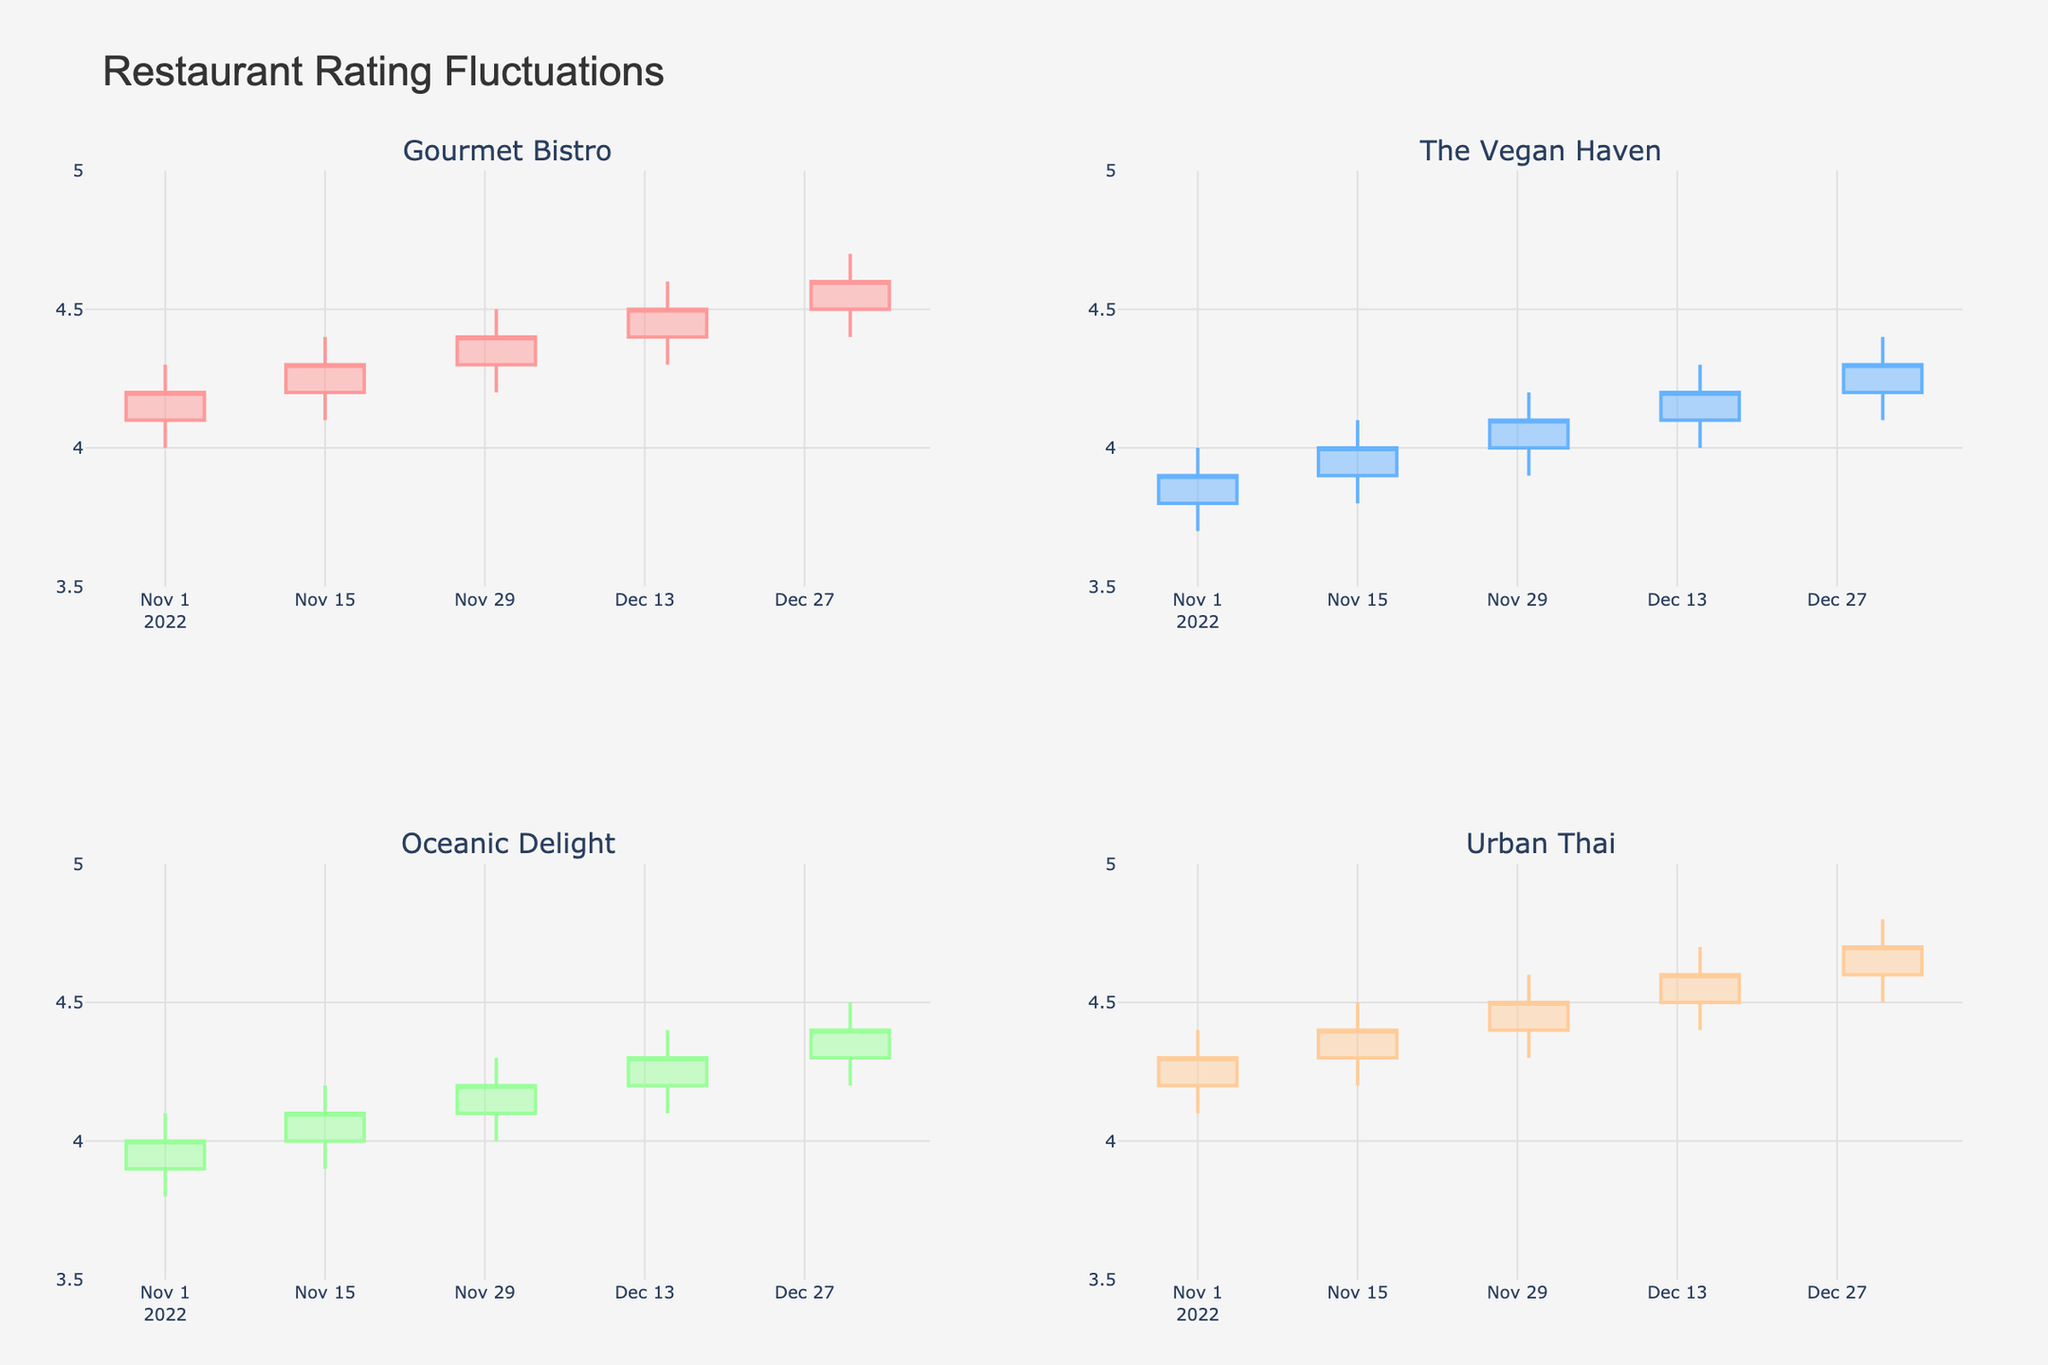What's the title of the figure? The title of the figure is provided at the top of the plot. By looking at the top of the figure, you can find that the title is "Restaurant Rating Fluctuations".
Answer: Restaurant Rating Fluctuations How many restaurants are shown in the figure? The subplot titles for each individual plot indicate a different restaurant name. By counting these titles, you see there are four restaurants shown.
Answer: Four What color indicates increasing ratings for "Urban Thai"? The color for increasing ratings can be identified by looking at the color of the candles that have the bottom line longer than the top line, indicating an increase. For "Urban Thai", this color is represented by a shade of blue.
Answer: Blue During which date did "The Vegan Haven" have its highest rating value? By examining the candlestick plot for "The Vegan Haven", you observe the highest point on the Y-axis within the range of Date values. The highest value is reached on 12/31/2022.
Answer: 12/31/2022 Which restaurant shows the most consistent increase in its ratings? To determine this, examine the trend in the heights of the candlesticks over time for each restaurant. "Gourmet Bistro" has a consistent upward trend in the majority of the dates shown in its plot.
Answer: Gourmet Bistro What is the difference between the opening rating on 11/01/2022 and the closing rating on 12/31/2022 for "Oceanic Delight"? From the plot for "Oceanic Delight," find the opening rating on 11/01/2022, which is 3.9, and the closing rating on 12/31/2022, which is 4.4. The difference is 4.4 - 3.9 = 0.5.
Answer: 0.5 Which restaurant showed the smallest fluctuation in ratings on 12/15/2022? Examine the candlesticks on 12/15/2022 for each restaurant and find the one with the shortest height (smallest high-low range). "Oceanic Delight" showed the smallest fluctuation as the difference between its high and low is the smallest.
Answer: Oceanic Delight Between "Gourmet Bistro" and "Urban Thai," which had a higher closing rating on 11/30/2022? Look at the closing rating value on 11/30/2022 for both restaurants. "Urban Thai" had a closing rating of 4.5, while "Gourmet Bistro" had 4.4. Thus, "Urban Thai" had a higher closing rating.
Answer: Urban Thai Which restaurant had a higher low rating on 12/15/2022, "Gourmet Bistro" or "The Vegan Haven"? Check the low points for these two restaurants on 12/15/2022. "Gourmet Bistro's" low rating was 4.3, and "The Vegan Haven's" low rating was 4.0. Therefore, "Gourmet Bistro" had a higher low rating.
Answer: Gourmet Bistro 